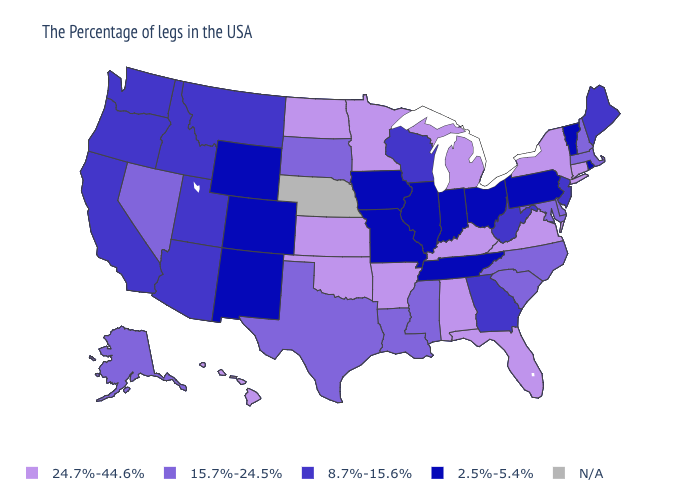Among the states that border Oklahoma , which have the highest value?
Answer briefly. Arkansas, Kansas. Does the map have missing data?
Answer briefly. Yes. What is the value of Michigan?
Give a very brief answer. 24.7%-44.6%. Among the states that border Nevada , which have the lowest value?
Write a very short answer. Utah, Arizona, Idaho, California, Oregon. What is the value of New Mexico?
Concise answer only. 2.5%-5.4%. What is the value of Oklahoma?
Be succinct. 24.7%-44.6%. Name the states that have a value in the range N/A?
Quick response, please. Nebraska. What is the value of Massachusetts?
Keep it brief. 15.7%-24.5%. What is the lowest value in the MidWest?
Concise answer only. 2.5%-5.4%. What is the highest value in the South ?
Answer briefly. 24.7%-44.6%. Which states have the lowest value in the MidWest?
Be succinct. Ohio, Indiana, Illinois, Missouri, Iowa. Does the map have missing data?
Keep it brief. Yes. How many symbols are there in the legend?
Quick response, please. 5. What is the value of Arizona?
Short answer required. 8.7%-15.6%. 